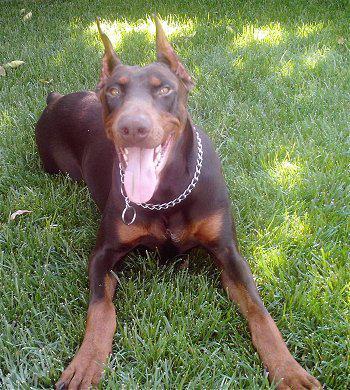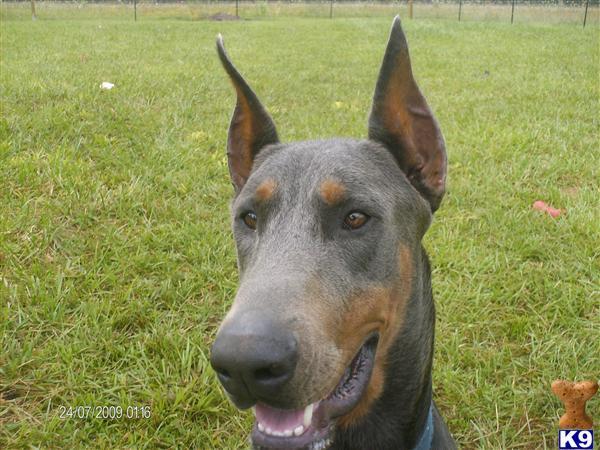The first image is the image on the left, the second image is the image on the right. For the images displayed, is the sentence "There is only one dog in each picture and both have similar positions." factually correct? Answer yes or no. No. The first image is the image on the left, the second image is the image on the right. For the images displayed, is the sentence "There is only one dog in each image and it has a collar on." factually correct? Answer yes or no. Yes. 